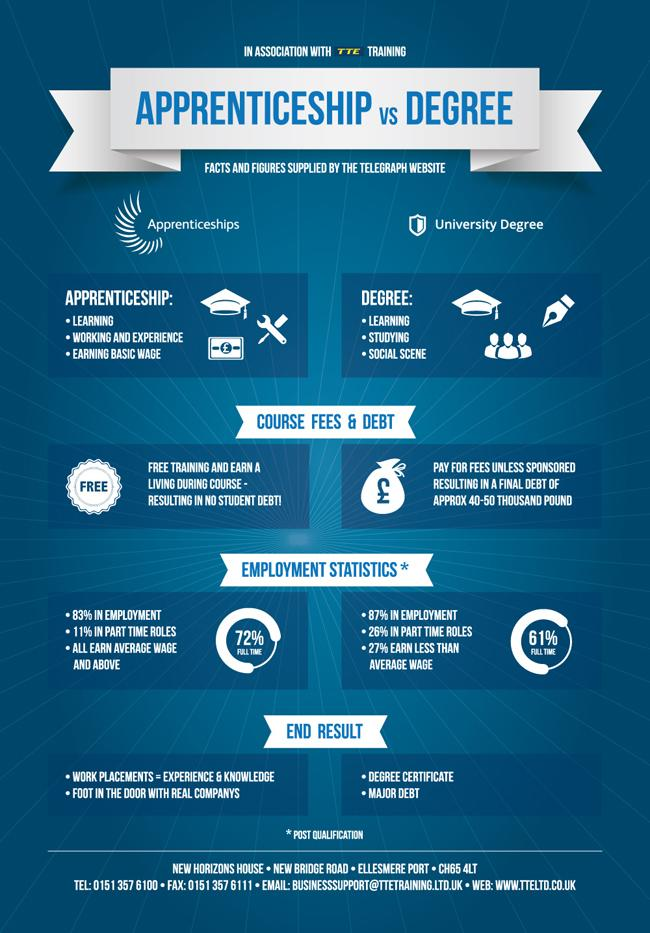Point out several critical features in this image. Apprenticeship is the type of education that provides debt-free learning. According to a recent study, 73% of degree holders earn an average wage or higher. Degree-granting educational institutions often perpetuate a type of learning that places undue financial burden on students. In prospective employees, employers highly value experience and knowledge. Apprenticeship is considered the most favorable type of education for securing a job. 